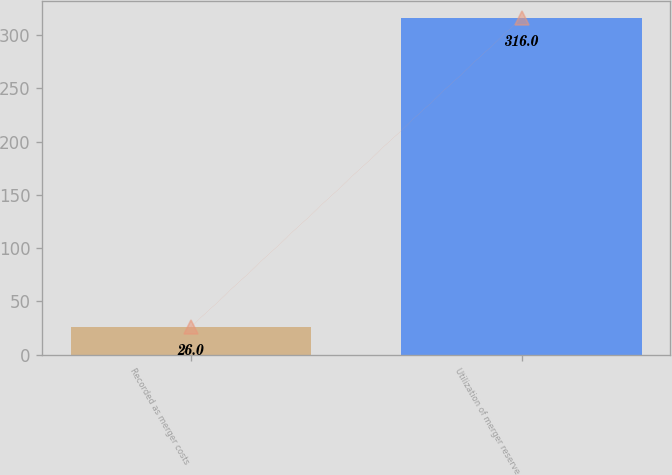Convert chart to OTSL. <chart><loc_0><loc_0><loc_500><loc_500><bar_chart><fcel>Recorded as merger costs<fcel>Utilization of merger reserve<nl><fcel>26<fcel>316<nl></chart> 